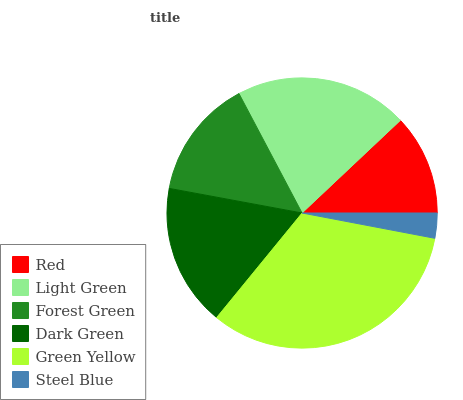Is Steel Blue the minimum?
Answer yes or no. Yes. Is Green Yellow the maximum?
Answer yes or no. Yes. Is Light Green the minimum?
Answer yes or no. No. Is Light Green the maximum?
Answer yes or no. No. Is Light Green greater than Red?
Answer yes or no. Yes. Is Red less than Light Green?
Answer yes or no. Yes. Is Red greater than Light Green?
Answer yes or no. No. Is Light Green less than Red?
Answer yes or no. No. Is Dark Green the high median?
Answer yes or no. Yes. Is Forest Green the low median?
Answer yes or no. Yes. Is Forest Green the high median?
Answer yes or no. No. Is Light Green the low median?
Answer yes or no. No. 